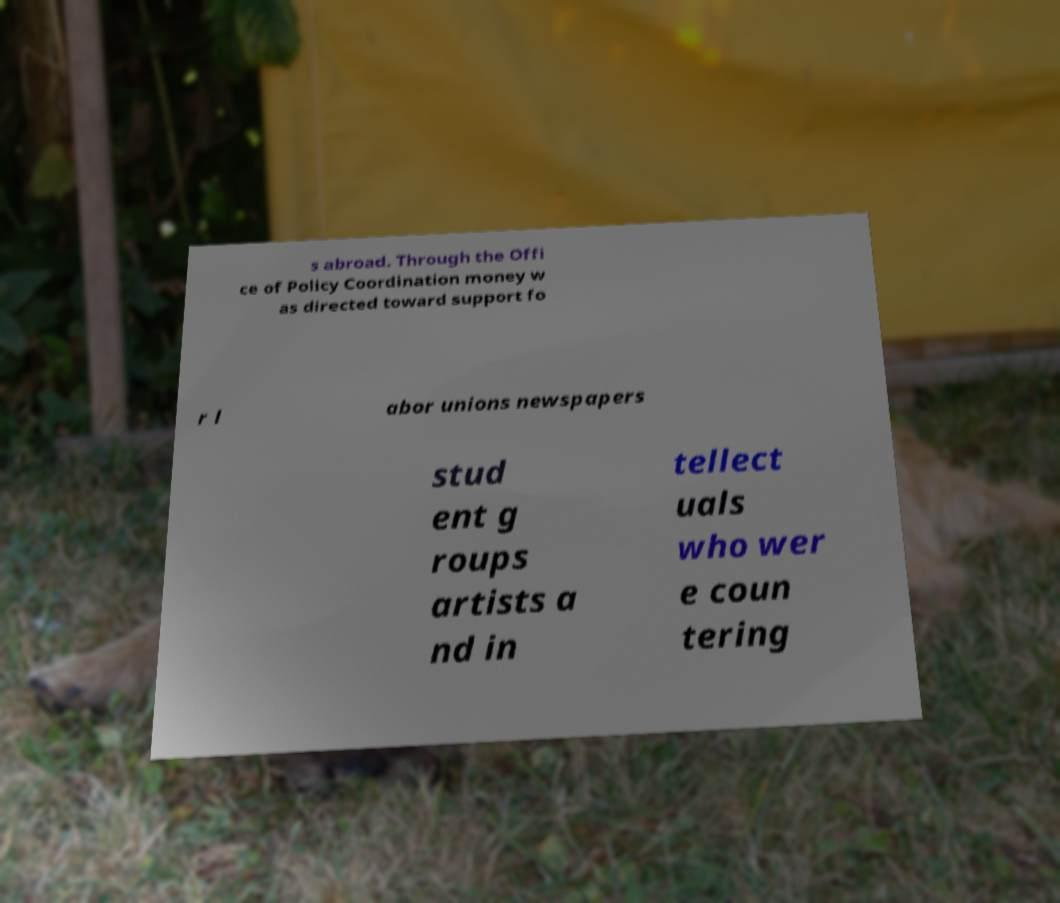I need the written content from this picture converted into text. Can you do that? s abroad. Through the Offi ce of Policy Coordination money w as directed toward support fo r l abor unions newspapers stud ent g roups artists a nd in tellect uals who wer e coun tering 